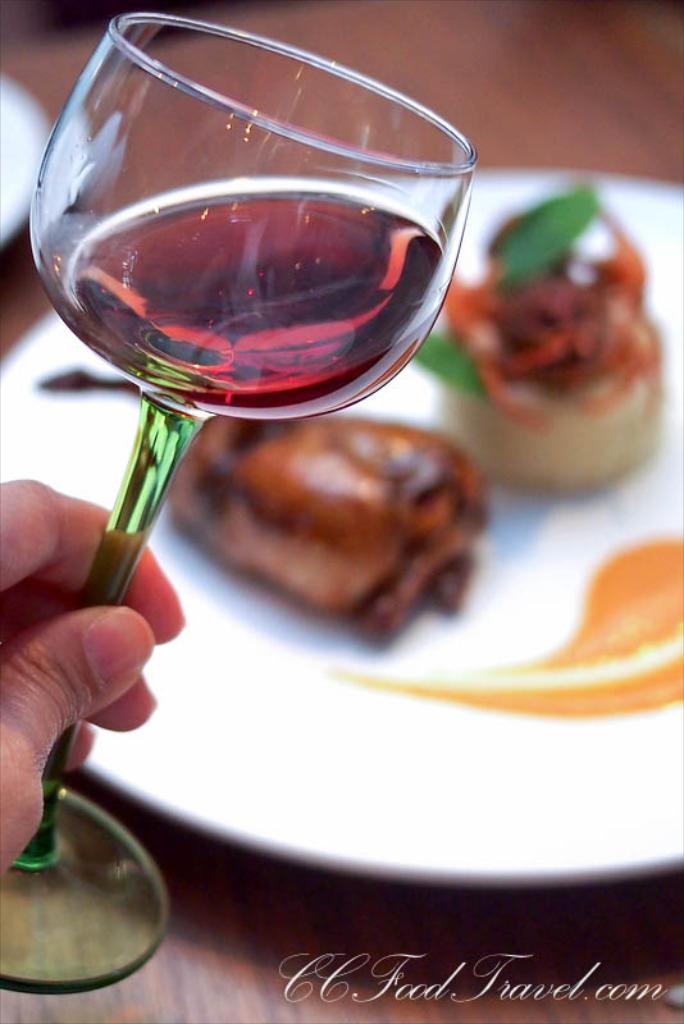In one or two sentences, can you explain what this image depicts? In this picture we can see a wooden surface. We can see food in a plate. On the left side of the picture we can see a person's hand holding a glass. We can see liquid in the glass. We can see an object. 